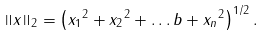Convert formula to latex. <formula><loc_0><loc_0><loc_500><loc_500>\left \| x \right \| _ { 2 } = \left ( { x _ { 1 } } ^ { 2 } + { x _ { 2 } } ^ { 2 } + \dots b + { x _ { n } } ^ { 2 } \right ) ^ { 1 / 2 } .</formula> 